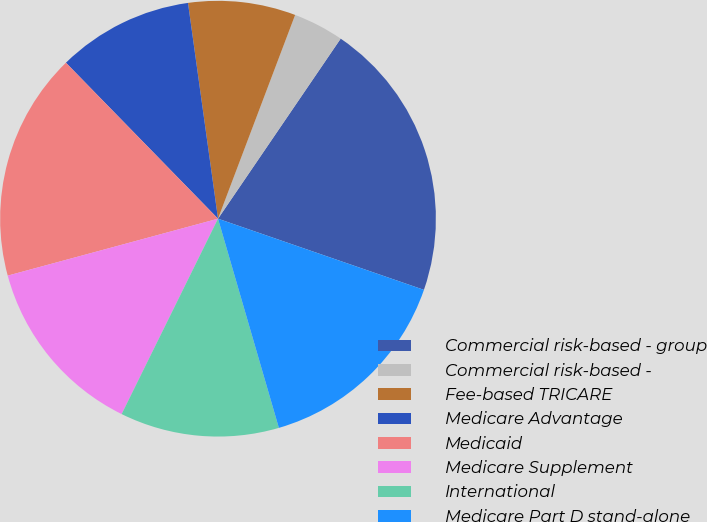Convert chart. <chart><loc_0><loc_0><loc_500><loc_500><pie_chart><fcel>Commercial risk-based - group<fcel>Commercial risk-based -<fcel>Fee-based TRICARE<fcel>Medicare Advantage<fcel>Medicaid<fcel>Medicare Supplement<fcel>International<fcel>Medicare Part D stand-alone<nl><fcel>20.78%<fcel>3.76%<fcel>7.96%<fcel>10.1%<fcel>16.91%<fcel>13.5%<fcel>11.8%<fcel>15.2%<nl></chart> 